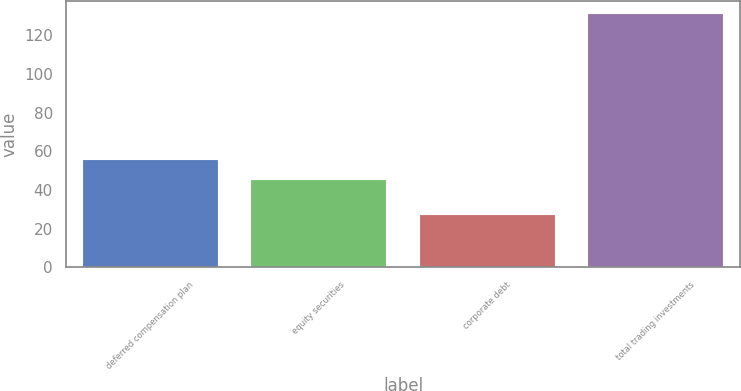<chart> <loc_0><loc_0><loc_500><loc_500><bar_chart><fcel>deferred compensation plan<fcel>equity securities<fcel>corporate debt<fcel>total trading investments<nl><fcel>55.4<fcel>45<fcel>27<fcel>131<nl></chart> 